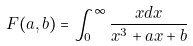<formula> <loc_0><loc_0><loc_500><loc_500>F ( a , b ) = \int _ { 0 } ^ { \infty } \frac { x d x } { x ^ { 3 } + a x + b }</formula> 